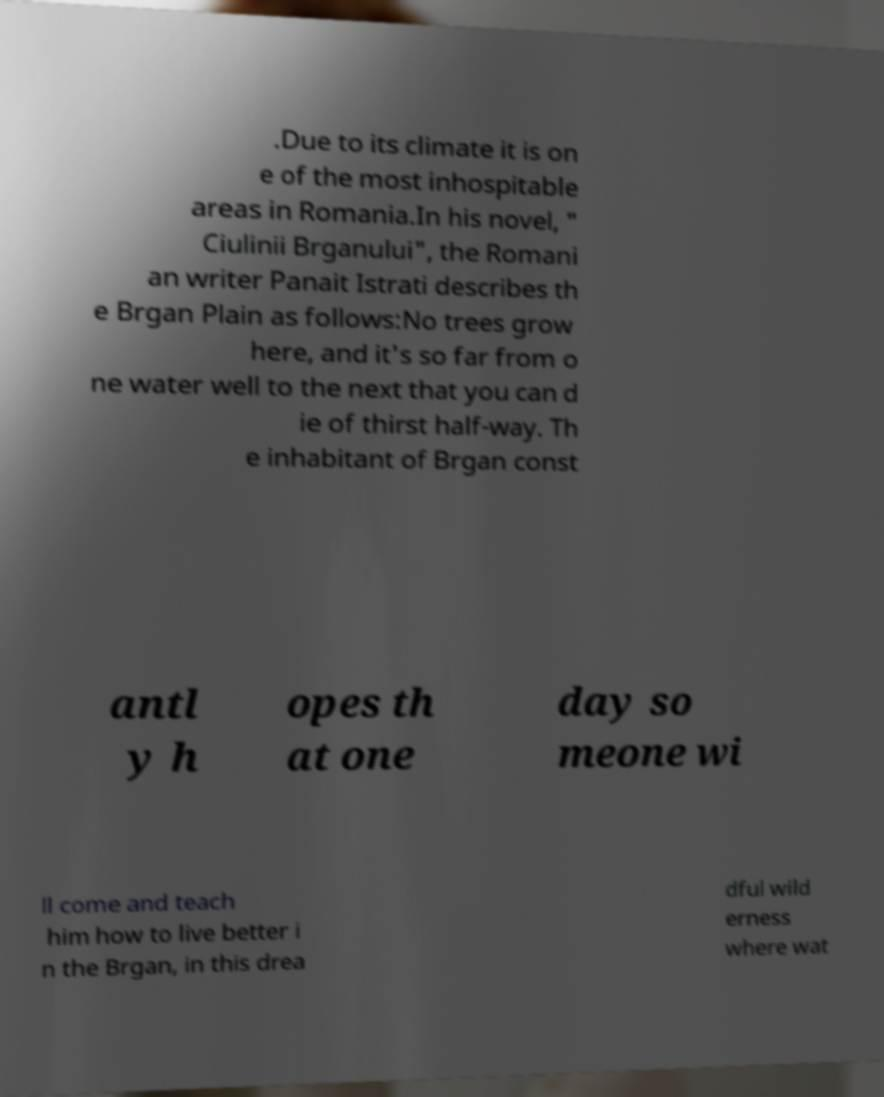Could you extract and type out the text from this image? .Due to its climate it is on e of the most inhospitable areas in Romania.In his novel, " Ciulinii Brganului", the Romani an writer Panait Istrati describes th e Brgan Plain as follows:No trees grow here, and it's so far from o ne water well to the next that you can d ie of thirst half-way. Th e inhabitant of Brgan const antl y h opes th at one day so meone wi ll come and teach him how to live better i n the Brgan, in this drea dful wild erness where wat 